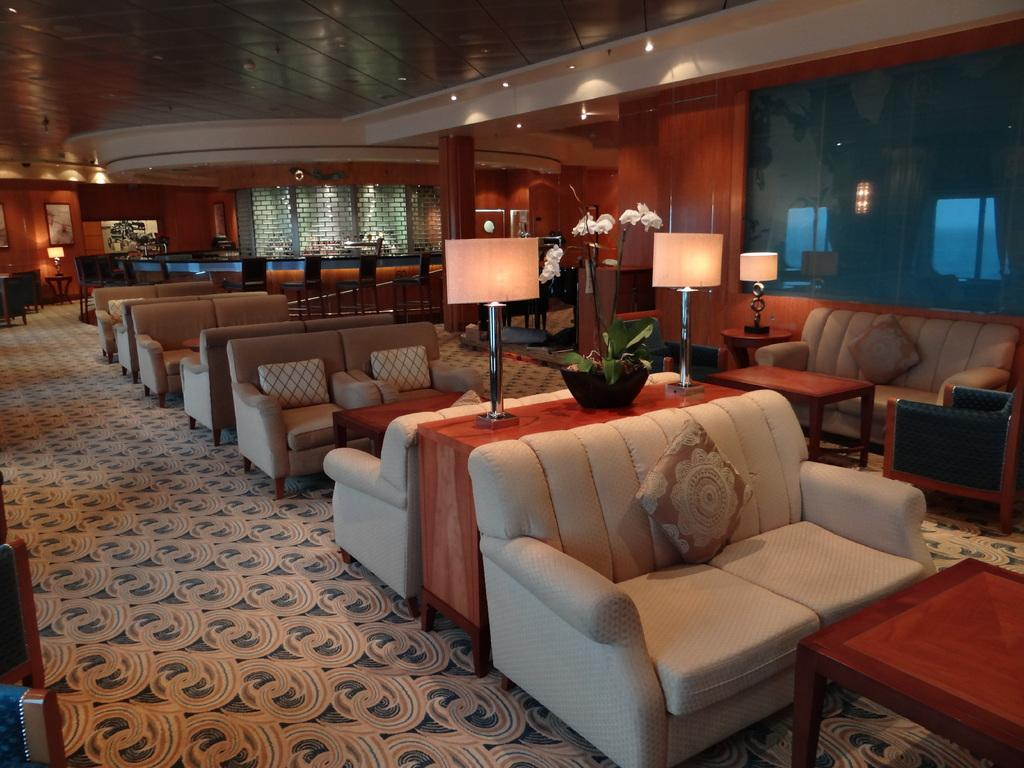Where was the image taken? The image was taken in a hotel. What type of furniture is present in the image? There are sofas and tables in the image. What can be seen on the desk in the image? Lights are present on the desk. What is located at the bottom of the image? There is a floor mat at the bottom of the image. What is visible at the top of the image? There is a roof visible at the top of the image. How many legs can be seen on the dock in the image? There is no dock present in the image. What type of observation can be made from the image? The image does not depict a scene where an observation can be made. 